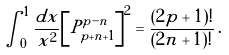Convert formula to latex. <formula><loc_0><loc_0><loc_500><loc_500>\int _ { 0 } ^ { 1 } \frac { d x } { x ^ { 2 } } { \left [ P _ { p + n + 1 } ^ { p - n } \right ] } ^ { 2 } = \frac { ( 2 p + 1 ) ! } { ( 2 n + 1 ) ! } \, .</formula> 